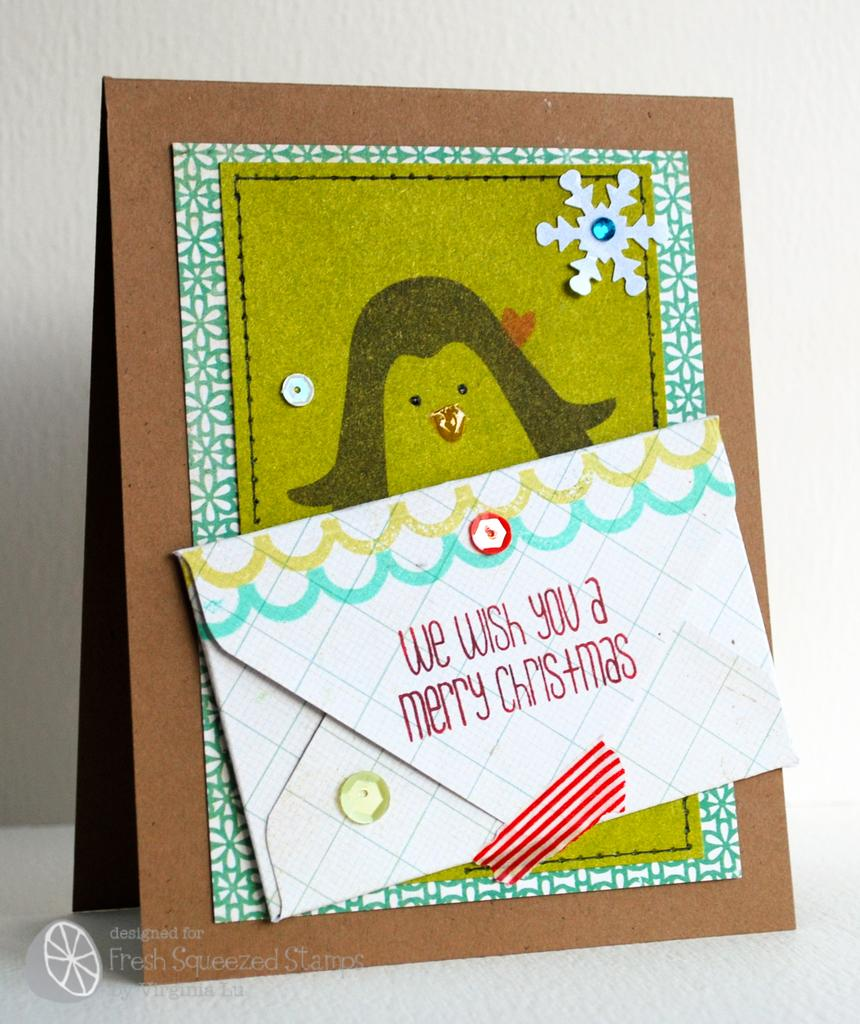<image>
Write a terse but informative summary of the picture. An envelope attached to a picture says We Wish You a Merry Christmas. 